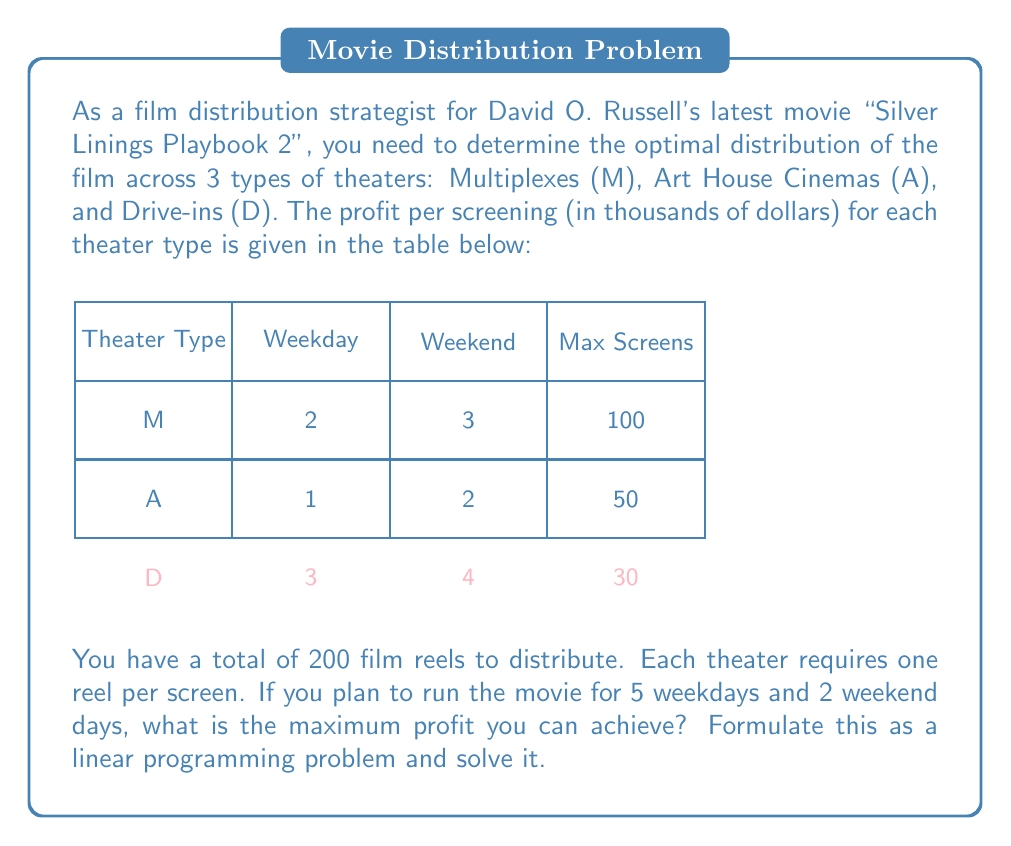Teach me how to tackle this problem. Let's approach this step-by-step:

1) Define variables:
   Let $x_M$, $x_A$, and $x_D$ be the number of screens allocated to Multiplexes, Art House Cinemas, and Drive-ins respectively.

2) Objective function:
   We want to maximize profit. For each type of theater, we multiply the number of screens by the profit per screening for weekdays (5 days) and weekends (2 days).
   
   Maximize: $Z = (5 \cdot 2 + 2 \cdot 3)x_M + (5 \cdot 1 + 2 \cdot 2)x_A + (5 \cdot 3 + 2 \cdot 4)x_D$
   
   Simplifying: Maximize $Z = 16x_M + 9x_A + 23x_D$

3) Constraints:
   a) Total reels: $x_M + x_A + x_D \leq 200$
   b) Maximum screens per theater type:
      $x_M \leq 100$
      $x_A \leq 50$
      $x_D \leq 30$
   c) Non-negativity: $x_M, x_A, x_D \geq 0$

4) Solving the linear programming problem:
   We can use the simplex method or a linear programming solver. The optimal solution is:
   $x_M = 100$, $x_A = 50$, $x_D = 30$

5) Calculate the maximum profit:
   $Z = 16(100) + 9(50) + 23(30) = 1600 + 450 + 690 = 2740$

Therefore, the maximum profit is 2,740 thousand dollars, or $2,740,000.
Answer: $2,740,000 